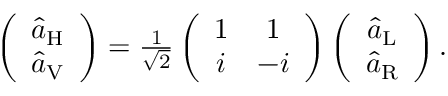Convert formula to latex. <formula><loc_0><loc_0><loc_500><loc_500>\begin{array} { r } { \left ( \begin{array} { c } { \hat { a } _ { H } } \\ { \hat { a } _ { V } } \end{array} \right ) = \frac { 1 } { \sqrt { 2 } } \left ( \begin{array} { c c } { 1 } & { 1 } \\ { i } & { - i } \end{array} \right ) \left ( \begin{array} { c } { \hat { a } _ { L } } \\ { \hat { a } _ { R } } \end{array} \right ) . } \end{array}</formula> 